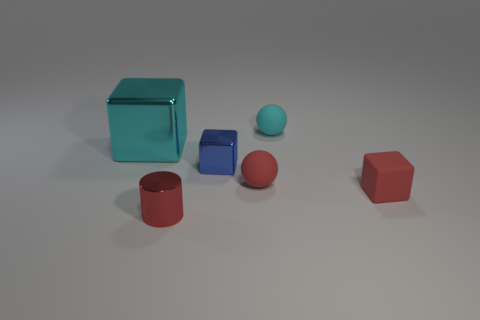Add 4 small blue objects. How many objects exist? 10 Subtract all balls. How many objects are left? 4 Subtract 0 yellow cylinders. How many objects are left? 6 Subtract all large cyan things. Subtract all small matte cubes. How many objects are left? 4 Add 3 blue blocks. How many blue blocks are left? 4 Add 5 big metallic things. How many big metallic things exist? 6 